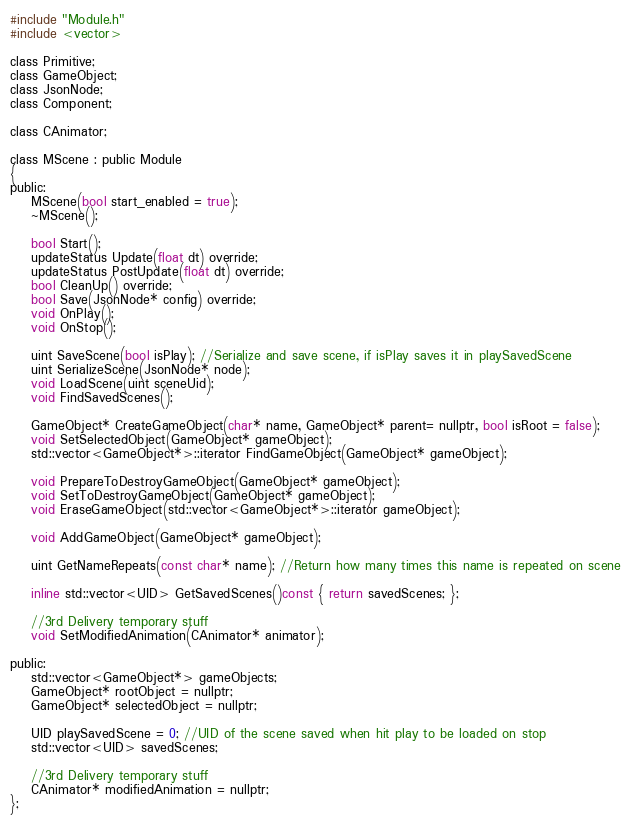<code> <loc_0><loc_0><loc_500><loc_500><_C_>#include "Module.h"
#include <vector>

class Primitive;
class GameObject;
class JsonNode;
class Component;

class CAnimator;

class MScene : public Module
{
public:
	MScene(bool start_enabled = true);
	~MScene();

	bool Start();
	updateStatus Update(float dt) override;
	updateStatus PostUpdate(float dt) override;
	bool CleanUp() override;
	bool Save(JsonNode* config) override;
	void OnPlay();
	void OnStop();

	uint SaveScene(bool isPlay); //Serialize and save scene, if isPlay saves it in playSavedScene
	uint SerializeScene(JsonNode* node);
	void LoadScene(uint sceneUid);
	void FindSavedScenes();

	GameObject* CreateGameObject(char* name, GameObject* parent= nullptr, bool isRoot = false);
	void SetSelectedObject(GameObject* gameObject);
	std::vector<GameObject*>::iterator FindGameObject(GameObject* gameObject);

	void PrepareToDestroyGameObject(GameObject* gameObject);
	void SetToDestroyGameObject(GameObject* gameObject);
	void EraseGameObject(std::vector<GameObject*>::iterator gameObject);

	void AddGameObject(GameObject* gameObject);

	uint GetNameRepeats(const char* name); //Return how many times this name is repeated on scene

	inline std::vector<UID> GetSavedScenes()const { return savedScenes; };

	//3rd Delivery temporary stuff
	void SetModifiedAnimation(CAnimator* animator);
	
public:
	std::vector<GameObject*> gameObjects;
	GameObject* rootObject = nullptr;
	GameObject* selectedObject = nullptr;

	UID playSavedScene = 0; //UID of the scene saved when hit play to be loaded on stop
	std::vector<UID> savedScenes;

	//3rd Delivery temporary stuff
	CAnimator* modifiedAnimation = nullptr;
};
</code> 